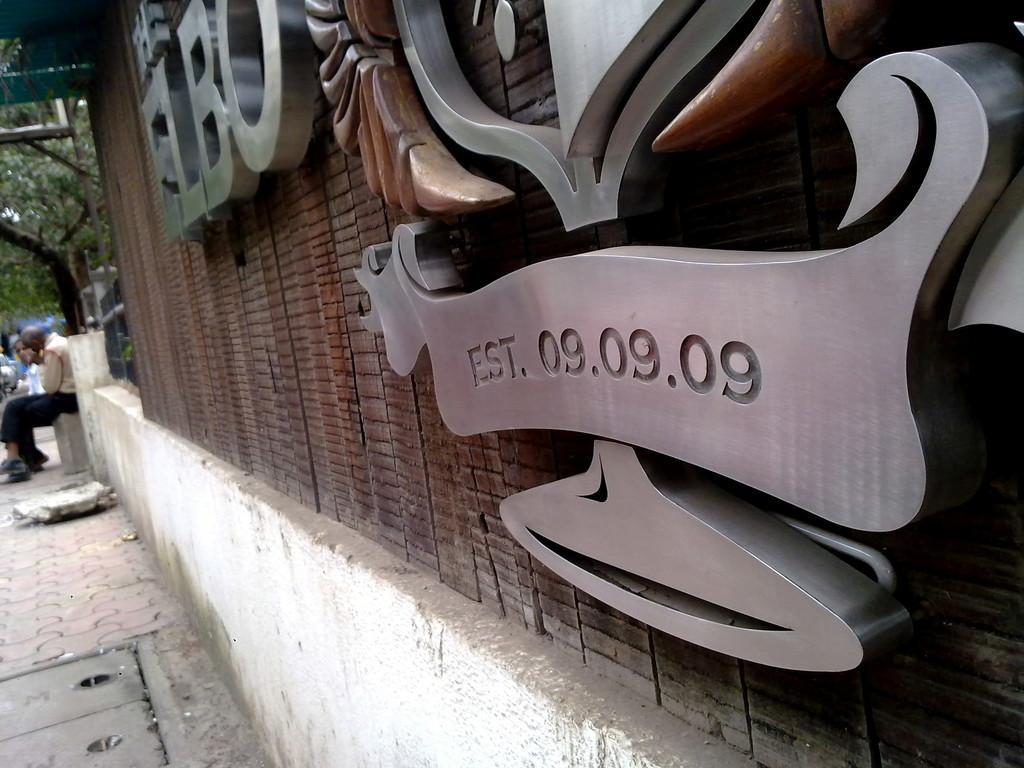Describe this image in one or two sentences. In this picture we can see boards on the wall and path. In the background of the image there are two people and we can see tree. 